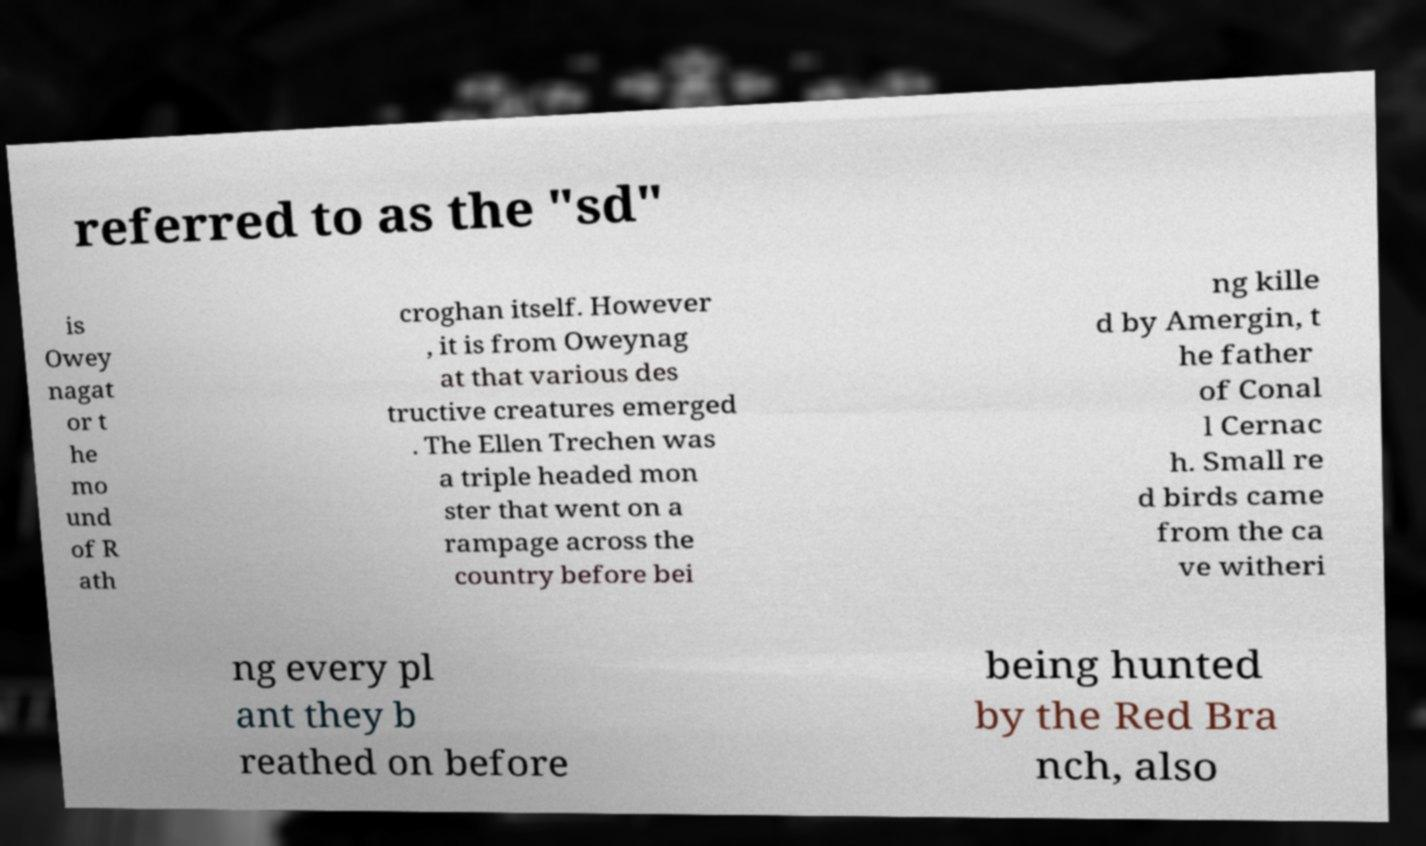Could you extract and type out the text from this image? referred to as the "sd" is Owey nagat or t he mo und of R ath croghan itself. However , it is from Oweynag at that various des tructive creatures emerged . The Ellen Trechen was a triple headed mon ster that went on a rampage across the country before bei ng kille d by Amergin, t he father of Conal l Cernac h. Small re d birds came from the ca ve witheri ng every pl ant they b reathed on before being hunted by the Red Bra nch, also 